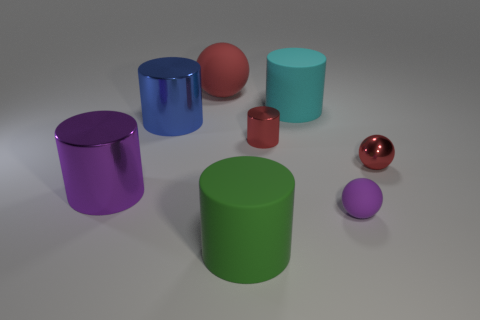How many objects are visible in the image, and can you describe their colors? There are seven objects in the image, each with a distinct color. From left to right: a purple cylinder, a blue cylinder, a red sphere, a cyan cylinder, a green cylinder, a small red cylinder, and a small purple sphere. 